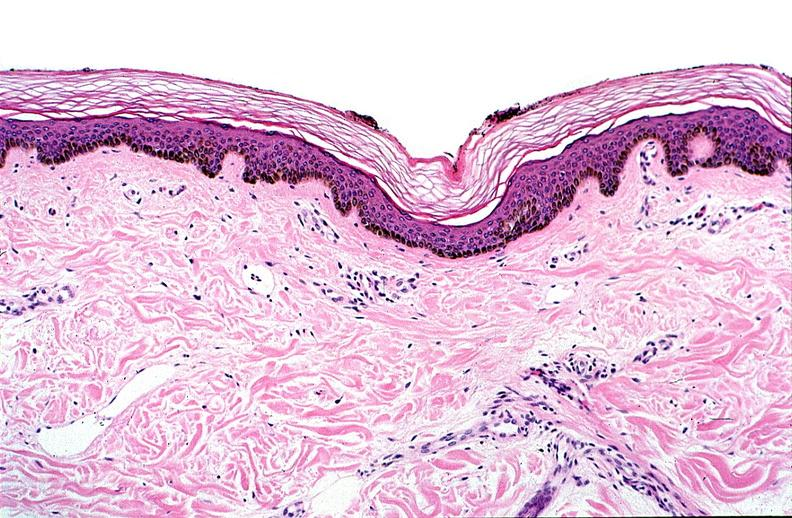does thymoma show thermal burned skin?
Answer the question using a single word or phrase. No 